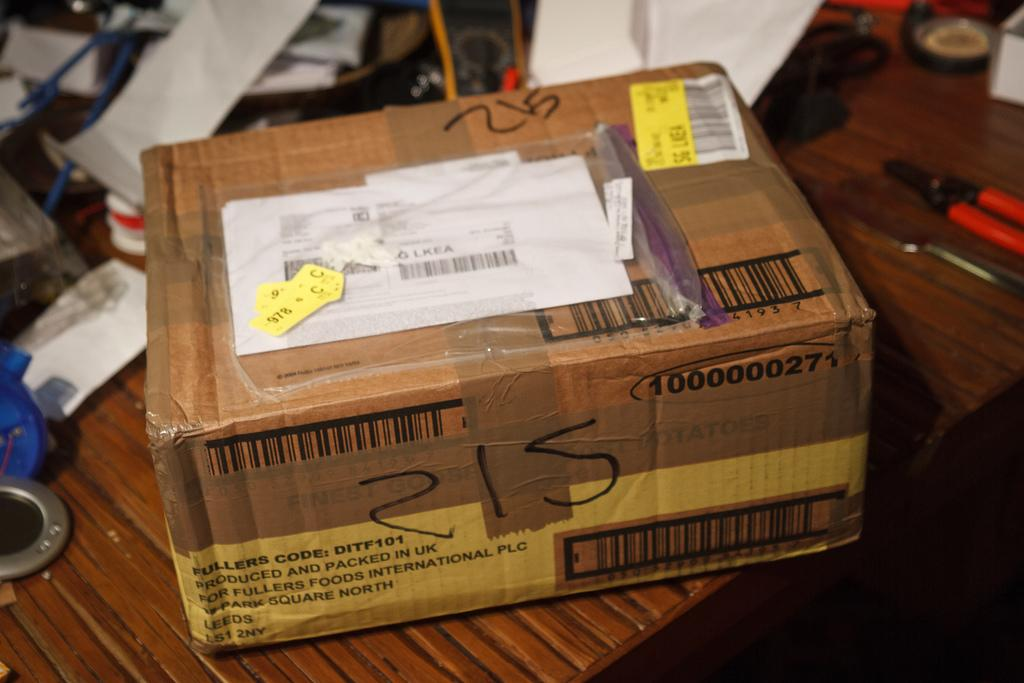Provide a one-sentence caption for the provided image. A package from UK is on the table with some other tools. 